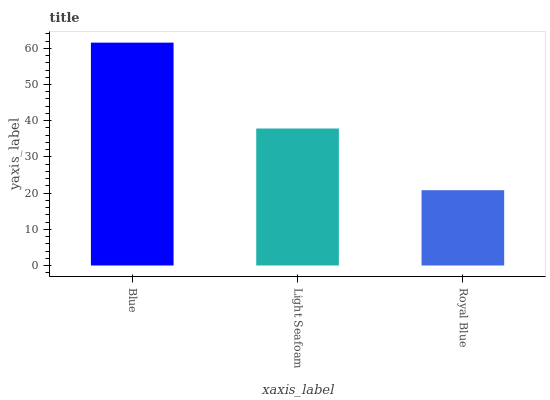Is Light Seafoam the minimum?
Answer yes or no. No. Is Light Seafoam the maximum?
Answer yes or no. No. Is Blue greater than Light Seafoam?
Answer yes or no. Yes. Is Light Seafoam less than Blue?
Answer yes or no. Yes. Is Light Seafoam greater than Blue?
Answer yes or no. No. Is Blue less than Light Seafoam?
Answer yes or no. No. Is Light Seafoam the high median?
Answer yes or no. Yes. Is Light Seafoam the low median?
Answer yes or no. Yes. Is Blue the high median?
Answer yes or no. No. Is Blue the low median?
Answer yes or no. No. 